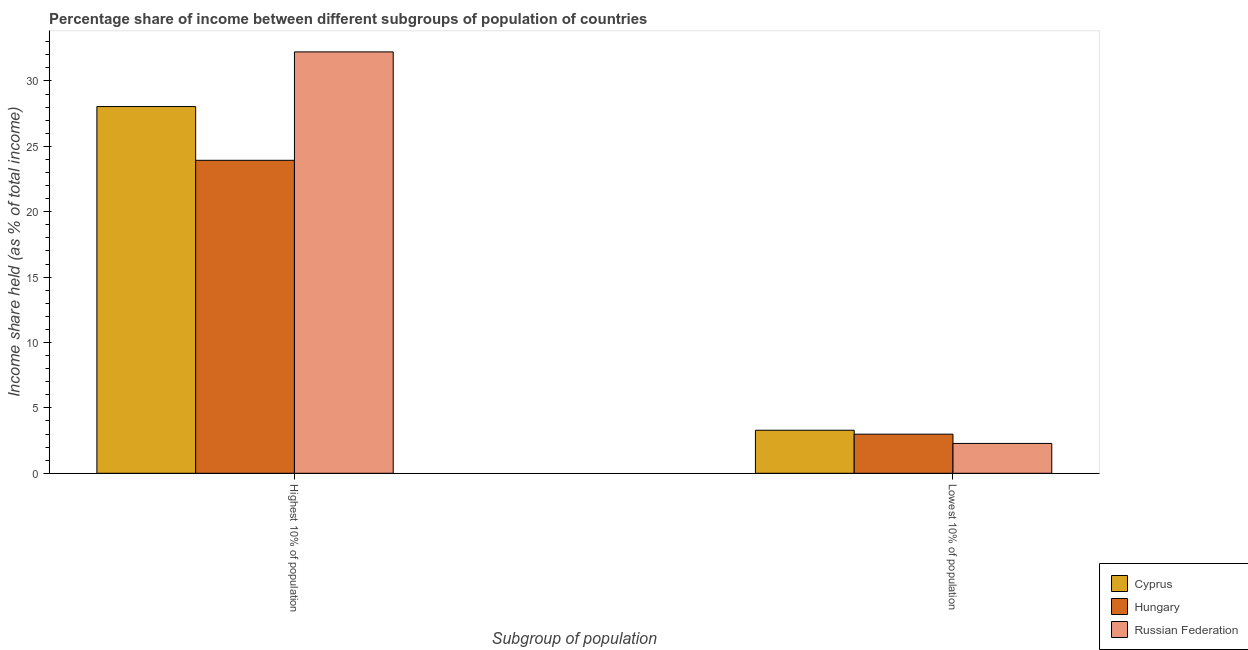How many groups of bars are there?
Your response must be concise. 2. Are the number of bars per tick equal to the number of legend labels?
Offer a very short reply. Yes. Are the number of bars on each tick of the X-axis equal?
Keep it short and to the point. Yes. How many bars are there on the 1st tick from the left?
Your answer should be very brief. 3. What is the label of the 2nd group of bars from the left?
Your answer should be compact. Lowest 10% of population. What is the income share held by lowest 10% of the population in Hungary?
Keep it short and to the point. 2.99. Across all countries, what is the maximum income share held by highest 10% of the population?
Offer a very short reply. 32.22. Across all countries, what is the minimum income share held by highest 10% of the population?
Your response must be concise. 23.93. In which country was the income share held by lowest 10% of the population maximum?
Your response must be concise. Cyprus. In which country was the income share held by lowest 10% of the population minimum?
Keep it short and to the point. Russian Federation. What is the total income share held by highest 10% of the population in the graph?
Ensure brevity in your answer.  84.19. What is the difference between the income share held by lowest 10% of the population in Hungary and that in Cyprus?
Make the answer very short. -0.3. What is the difference between the income share held by lowest 10% of the population in Hungary and the income share held by highest 10% of the population in Cyprus?
Your answer should be very brief. -25.05. What is the average income share held by lowest 10% of the population per country?
Your response must be concise. 2.85. What is the difference between the income share held by highest 10% of the population and income share held by lowest 10% of the population in Hungary?
Keep it short and to the point. 20.94. What is the ratio of the income share held by highest 10% of the population in Cyprus to that in Russian Federation?
Provide a succinct answer. 0.87. Is the income share held by lowest 10% of the population in Hungary less than that in Cyprus?
Give a very brief answer. Yes. What does the 1st bar from the left in Highest 10% of population represents?
Provide a short and direct response. Cyprus. What does the 3rd bar from the right in Highest 10% of population represents?
Provide a succinct answer. Cyprus. Are all the bars in the graph horizontal?
Provide a short and direct response. No. Are the values on the major ticks of Y-axis written in scientific E-notation?
Your answer should be very brief. No. How are the legend labels stacked?
Provide a succinct answer. Vertical. What is the title of the graph?
Make the answer very short. Percentage share of income between different subgroups of population of countries. What is the label or title of the X-axis?
Give a very brief answer. Subgroup of population. What is the label or title of the Y-axis?
Give a very brief answer. Income share held (as % of total income). What is the Income share held (as % of total income) of Cyprus in Highest 10% of population?
Give a very brief answer. 28.04. What is the Income share held (as % of total income) in Hungary in Highest 10% of population?
Ensure brevity in your answer.  23.93. What is the Income share held (as % of total income) of Russian Federation in Highest 10% of population?
Keep it short and to the point. 32.22. What is the Income share held (as % of total income) of Cyprus in Lowest 10% of population?
Give a very brief answer. 3.29. What is the Income share held (as % of total income) in Hungary in Lowest 10% of population?
Make the answer very short. 2.99. What is the Income share held (as % of total income) of Russian Federation in Lowest 10% of population?
Offer a very short reply. 2.28. Across all Subgroup of population, what is the maximum Income share held (as % of total income) in Cyprus?
Offer a very short reply. 28.04. Across all Subgroup of population, what is the maximum Income share held (as % of total income) in Hungary?
Your response must be concise. 23.93. Across all Subgroup of population, what is the maximum Income share held (as % of total income) in Russian Federation?
Ensure brevity in your answer.  32.22. Across all Subgroup of population, what is the minimum Income share held (as % of total income) in Cyprus?
Your answer should be compact. 3.29. Across all Subgroup of population, what is the minimum Income share held (as % of total income) of Hungary?
Your answer should be very brief. 2.99. Across all Subgroup of population, what is the minimum Income share held (as % of total income) of Russian Federation?
Offer a very short reply. 2.28. What is the total Income share held (as % of total income) in Cyprus in the graph?
Provide a short and direct response. 31.33. What is the total Income share held (as % of total income) in Hungary in the graph?
Offer a terse response. 26.92. What is the total Income share held (as % of total income) of Russian Federation in the graph?
Offer a very short reply. 34.5. What is the difference between the Income share held (as % of total income) of Cyprus in Highest 10% of population and that in Lowest 10% of population?
Offer a terse response. 24.75. What is the difference between the Income share held (as % of total income) of Hungary in Highest 10% of population and that in Lowest 10% of population?
Offer a very short reply. 20.94. What is the difference between the Income share held (as % of total income) of Russian Federation in Highest 10% of population and that in Lowest 10% of population?
Make the answer very short. 29.94. What is the difference between the Income share held (as % of total income) of Cyprus in Highest 10% of population and the Income share held (as % of total income) of Hungary in Lowest 10% of population?
Provide a short and direct response. 25.05. What is the difference between the Income share held (as % of total income) in Cyprus in Highest 10% of population and the Income share held (as % of total income) in Russian Federation in Lowest 10% of population?
Your answer should be compact. 25.76. What is the difference between the Income share held (as % of total income) in Hungary in Highest 10% of population and the Income share held (as % of total income) in Russian Federation in Lowest 10% of population?
Provide a succinct answer. 21.65. What is the average Income share held (as % of total income) of Cyprus per Subgroup of population?
Your answer should be compact. 15.66. What is the average Income share held (as % of total income) of Hungary per Subgroup of population?
Offer a terse response. 13.46. What is the average Income share held (as % of total income) of Russian Federation per Subgroup of population?
Offer a very short reply. 17.25. What is the difference between the Income share held (as % of total income) of Cyprus and Income share held (as % of total income) of Hungary in Highest 10% of population?
Provide a succinct answer. 4.11. What is the difference between the Income share held (as % of total income) in Cyprus and Income share held (as % of total income) in Russian Federation in Highest 10% of population?
Offer a terse response. -4.18. What is the difference between the Income share held (as % of total income) of Hungary and Income share held (as % of total income) of Russian Federation in Highest 10% of population?
Provide a short and direct response. -8.29. What is the difference between the Income share held (as % of total income) of Cyprus and Income share held (as % of total income) of Russian Federation in Lowest 10% of population?
Your answer should be very brief. 1.01. What is the difference between the Income share held (as % of total income) of Hungary and Income share held (as % of total income) of Russian Federation in Lowest 10% of population?
Ensure brevity in your answer.  0.71. What is the ratio of the Income share held (as % of total income) of Cyprus in Highest 10% of population to that in Lowest 10% of population?
Ensure brevity in your answer.  8.52. What is the ratio of the Income share held (as % of total income) of Hungary in Highest 10% of population to that in Lowest 10% of population?
Provide a succinct answer. 8. What is the ratio of the Income share held (as % of total income) in Russian Federation in Highest 10% of population to that in Lowest 10% of population?
Ensure brevity in your answer.  14.13. What is the difference between the highest and the second highest Income share held (as % of total income) in Cyprus?
Make the answer very short. 24.75. What is the difference between the highest and the second highest Income share held (as % of total income) of Hungary?
Your answer should be very brief. 20.94. What is the difference between the highest and the second highest Income share held (as % of total income) in Russian Federation?
Give a very brief answer. 29.94. What is the difference between the highest and the lowest Income share held (as % of total income) of Cyprus?
Give a very brief answer. 24.75. What is the difference between the highest and the lowest Income share held (as % of total income) of Hungary?
Provide a succinct answer. 20.94. What is the difference between the highest and the lowest Income share held (as % of total income) in Russian Federation?
Your answer should be compact. 29.94. 